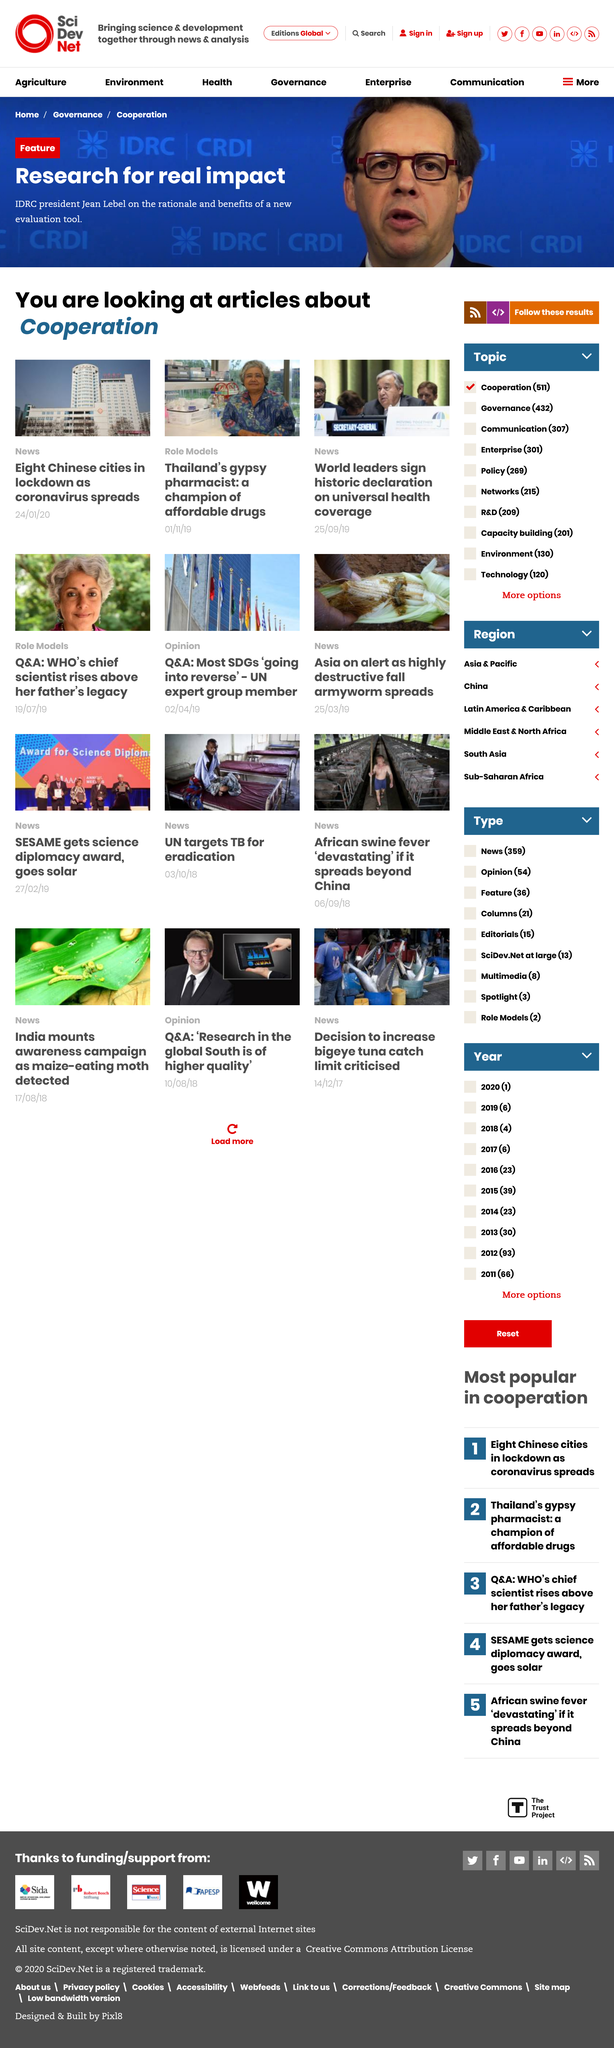Point out several critical features in this image. On December 12th, 2019, world leaders signed a historic declaration on universal health coverage. This declaration represents a monumental step towards ensuring that everyone, everywhere, has access to quality healthcare. By signing this declaration, world leaders have committed to working together to improve healthcare systems and increase access to essential health services for all. The signing of this declaration is a testament to the collective determination of nations to prioritize the health and well-being of their citizens. Thailand's gypsy pharmacist is recognized as a champion of affordable drugs in the Role Models article category. The article on the lockdown of eight Chinese cities was published on January 24, 2023. 